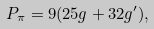Convert formula to latex. <formula><loc_0><loc_0><loc_500><loc_500>P _ { \pi } = 9 ( 2 5 g + 3 2 g ^ { \prime } ) ,</formula> 